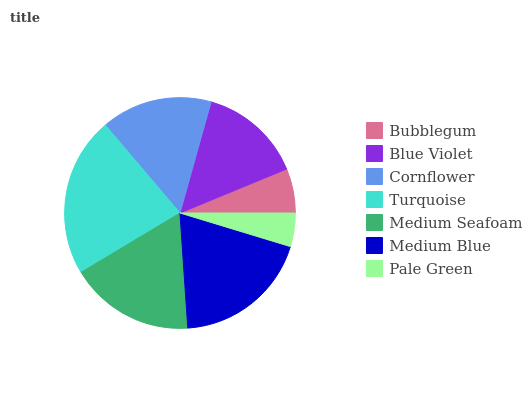Is Pale Green the minimum?
Answer yes or no. Yes. Is Turquoise the maximum?
Answer yes or no. Yes. Is Blue Violet the minimum?
Answer yes or no. No. Is Blue Violet the maximum?
Answer yes or no. No. Is Blue Violet greater than Bubblegum?
Answer yes or no. Yes. Is Bubblegum less than Blue Violet?
Answer yes or no. Yes. Is Bubblegum greater than Blue Violet?
Answer yes or no. No. Is Blue Violet less than Bubblegum?
Answer yes or no. No. Is Cornflower the high median?
Answer yes or no. Yes. Is Cornflower the low median?
Answer yes or no. Yes. Is Turquoise the high median?
Answer yes or no. No. Is Turquoise the low median?
Answer yes or no. No. 